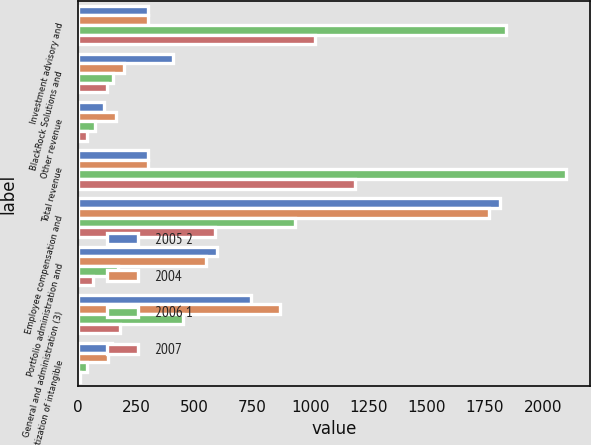Convert chart. <chart><loc_0><loc_0><loc_500><loc_500><stacked_bar_chart><ecel><fcel>Investment advisory and<fcel>BlackRock Solutions and<fcel>Other revenue<fcel>Total revenue<fcel>Employee compensation and<fcel>Portfolio administration and<fcel>General and administration (3)<fcel>Amortization of intangible<nl><fcel>2005 2<fcel>302<fcel>406<fcel>110<fcel>302<fcel>1815<fcel>597<fcel>745<fcel>146<nl><fcel>2004<fcel>302<fcel>198<fcel>164<fcel>302<fcel>1767<fcel>548<fcel>870<fcel>130<nl><fcel>2006 1<fcel>1841<fcel>148<fcel>73<fcel>2098<fcel>934<fcel>173<fcel>451<fcel>38<nl><fcel>2007<fcel>1018<fcel>124<fcel>38<fcel>1191<fcel>588<fcel>64<fcel>181<fcel>8<nl></chart> 